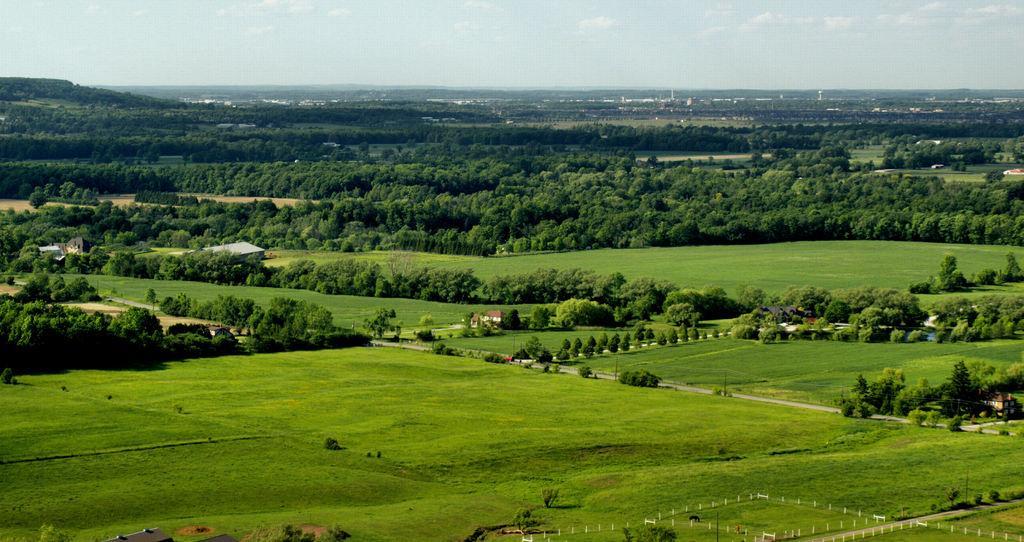In one or two sentences, can you explain what this image depicts? In this image we can see there are houses, trees, grass and poles arranged in an order. And there are animals on the ground. And at the top we can see the sky. 